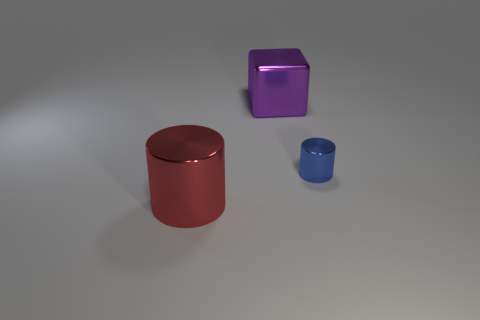Are there more tiny blue shiny cubes than large purple metal objects?
Provide a short and direct response. No. What material is the blue thing?
Ensure brevity in your answer.  Metal. Is the size of the metal thing on the right side of the purple metallic block the same as the purple block?
Keep it short and to the point. No. There is a metallic cylinder that is to the left of the shiny cube; what size is it?
Ensure brevity in your answer.  Large. Is there anything else that is made of the same material as the red cylinder?
Your answer should be very brief. Yes. How many tiny gray rubber balls are there?
Keep it short and to the point. 0. Do the big cube and the large cylinder have the same color?
Offer a very short reply. No. What color is the metal thing that is both in front of the metal block and on the left side of the blue metal object?
Provide a short and direct response. Red. There is a large shiny cylinder; are there any tiny blue metallic things left of it?
Give a very brief answer. No. There is a big purple cube to the right of the big red thing; what number of cylinders are behind it?
Your answer should be very brief. 0. 